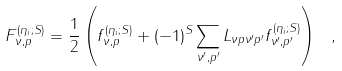Convert formula to latex. <formula><loc_0><loc_0><loc_500><loc_500>F _ { \nu , p } ^ { ( \eta _ { i } ; S ) } = \frac { 1 } { 2 } \left ( f _ { \nu , p } ^ { ( \eta _ { i } ; S ) } + ( - 1 ) ^ { S } \sum _ { \nu ^ { \prime } , p ^ { \prime } } L _ { \nu p \nu ^ { \prime } p ^ { \prime } } f _ { \nu ^ { \prime } , p ^ { \prime } } ^ { ( \eta _ { i } ; S ) } \right ) \ ,</formula> 